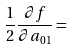Convert formula to latex. <formula><loc_0><loc_0><loc_500><loc_500>\frac { 1 } { 2 } \frac { \partial f } { \partial a _ { 0 1 } } =</formula> 